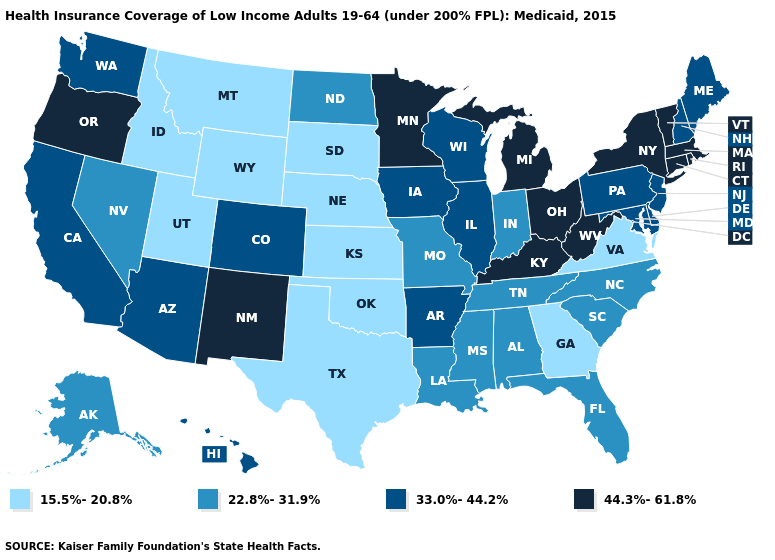What is the value of Alabama?
Concise answer only. 22.8%-31.9%. Name the states that have a value in the range 44.3%-61.8%?
Be succinct. Connecticut, Kentucky, Massachusetts, Michigan, Minnesota, New Mexico, New York, Ohio, Oregon, Rhode Island, Vermont, West Virginia. Does the first symbol in the legend represent the smallest category?
Write a very short answer. Yes. Name the states that have a value in the range 33.0%-44.2%?
Answer briefly. Arizona, Arkansas, California, Colorado, Delaware, Hawaii, Illinois, Iowa, Maine, Maryland, New Hampshire, New Jersey, Pennsylvania, Washington, Wisconsin. What is the value of Oklahoma?
Keep it brief. 15.5%-20.8%. What is the value of South Carolina?
Give a very brief answer. 22.8%-31.9%. Among the states that border South Carolina , does North Carolina have the lowest value?
Answer briefly. No. What is the value of Vermont?
Give a very brief answer. 44.3%-61.8%. Name the states that have a value in the range 22.8%-31.9%?
Be succinct. Alabama, Alaska, Florida, Indiana, Louisiana, Mississippi, Missouri, Nevada, North Carolina, North Dakota, South Carolina, Tennessee. What is the value of Washington?
Give a very brief answer. 33.0%-44.2%. Name the states that have a value in the range 22.8%-31.9%?
Short answer required. Alabama, Alaska, Florida, Indiana, Louisiana, Mississippi, Missouri, Nevada, North Carolina, North Dakota, South Carolina, Tennessee. Which states hav the highest value in the Northeast?
Keep it brief. Connecticut, Massachusetts, New York, Rhode Island, Vermont. Which states have the lowest value in the MidWest?
Answer briefly. Kansas, Nebraska, South Dakota. Does the first symbol in the legend represent the smallest category?
Write a very short answer. Yes. 